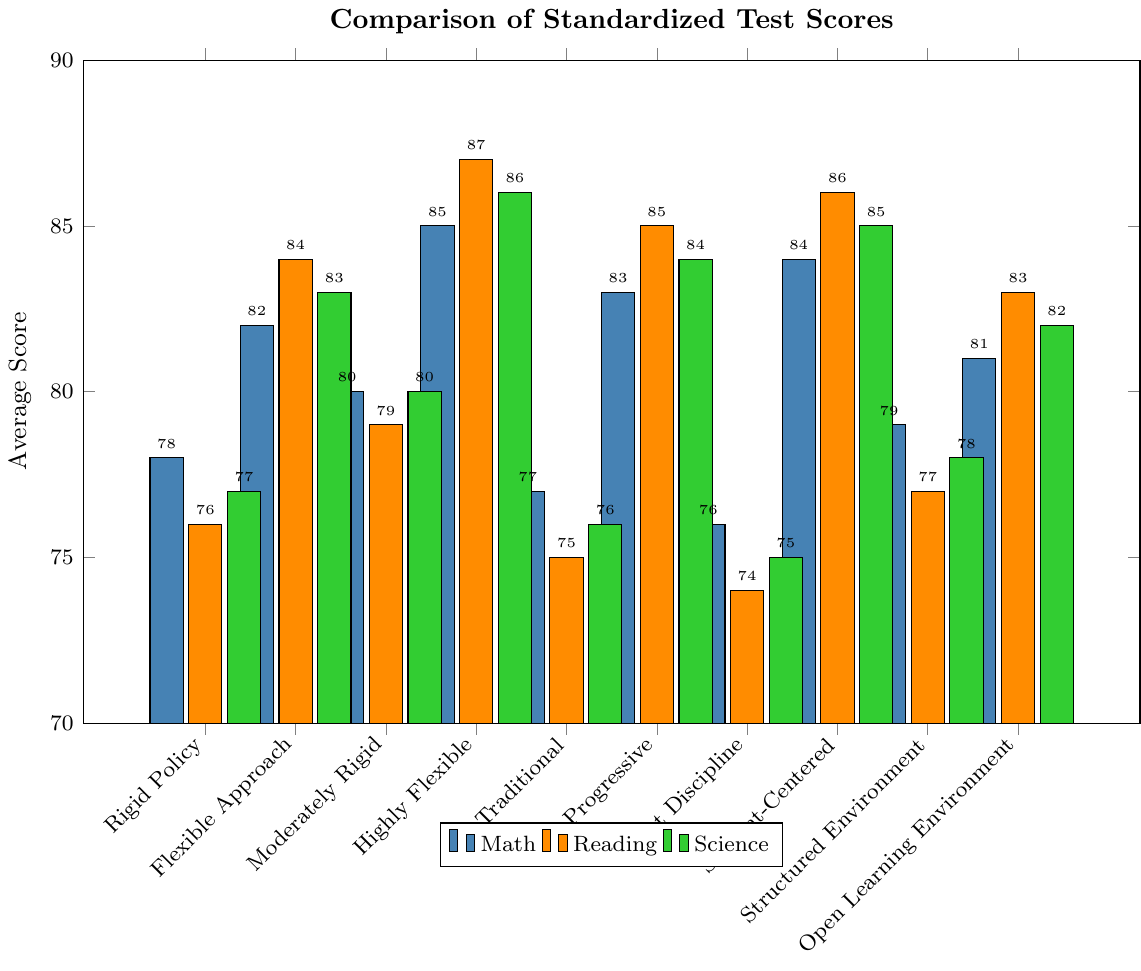How do the average math scores compare between Rigid Policy Schools and Flexible Approach Schools? The average math scores for Rigid Policy Schools and Flexible Approach Schools can be compared directly by looking at the bars representing these schools. The bar for Rigid Policy Schools has a height of 78, while the bar for Flexible Approach Schools has a height of 82. Therefore, the average math scores are higher for Flexible Approach Schools.
Answer: 82 > 78 Which school type has the highest average reading score? To find the school type with the highest average reading score, we need to identify the tallest bar in the reading score series (orange bars). The tallest reading score bar corresponds to Highly Flexible Schools with an average reading score of 87.
Answer: Highly Flexible Schools What is the average science score difference between Strict Discipline Schools and Student-Centered Schools? We need to find the science scores for Strict Discipline Schools and Student-Centered Schools represented by the green bars. Strict Discipline Schools have an average science score of 75, and Student-Centered Schools have an average science score of 85. The difference is 85 - 75.
Answer: 10 Among all school types, which one has the most consistent average scores across all subjects (math, reading, science)? Consistency can be observed by assessing the bars' heights for each school type. We look for the school whose bars are closest in height for all three subjects. Both Student-Centered Schools and Highly Flexible Schools show highly consistent scores, each having differences of about 1 point between their subjects.
Answer: Student-Centered Schools or Highly Flexible Schools What is the total sum of average scores across all subjects for Traditional Schools? Sum the average math, reading, and science scores for Traditional Schools. The values are 77 (math) + 75 (reading) + 76 (science). The total sum is 77 + 75 + 76.
Answer: 228 Which school type has a lower average science score compared to its average math score? To determine this, we compare the heights of the green and blue bars for each school type. For Structured Environment Schools, the average math score is 79, and the average science score is 78. Since 78 is lower than 79, Structured Environment Schools meet this condition.
Answer: Structured Environment Schools How much higher is the average reading score of Progressive Schools compared to Rigid Policy Schools? The reading score for Progressive Schools is 85 and for Rigid Policy Schools is 76. The difference can be calculated as 85 - 76.
Answer: 9 Calculate the average of the average math scores for all the school types presented. Sum up the average math scores for all school types and divide by the number of school types (10). The scores are 78, 82, 80, 85, 77, 83, 76, 84, 79, 81. Sum = 78 + 82 + 80 + 85 + 77 + 83 + 76 + 84 + 79 + 81 = 805. Divide by 10 to find the average.
Answer: 80.5 What is the difference between the highest and lowest average reading scores across all school types? Identify the highest and lowest reading scores from the bars representing reading scores. The highest reading score is 87 (Highly Flexible Schools) and the lowest is 74 (Strict Discipline Schools). The difference is 87 - 74.
Answer: 13 